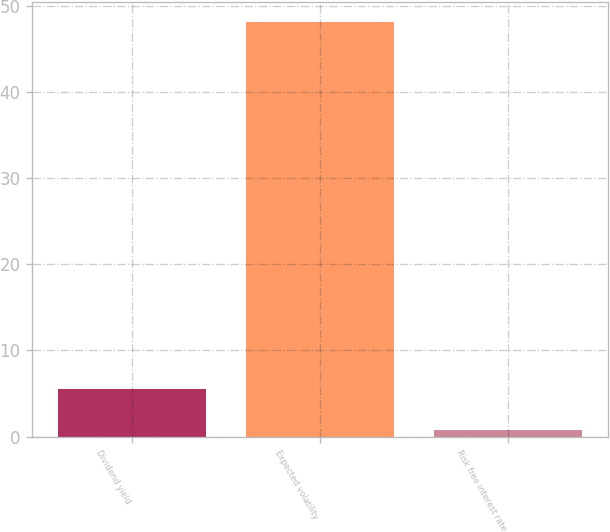<chart> <loc_0><loc_0><loc_500><loc_500><bar_chart><fcel>Dividend yield<fcel>Expected volatility<fcel>Risk free interest rate<nl><fcel>5.48<fcel>48.1<fcel>0.74<nl></chart> 